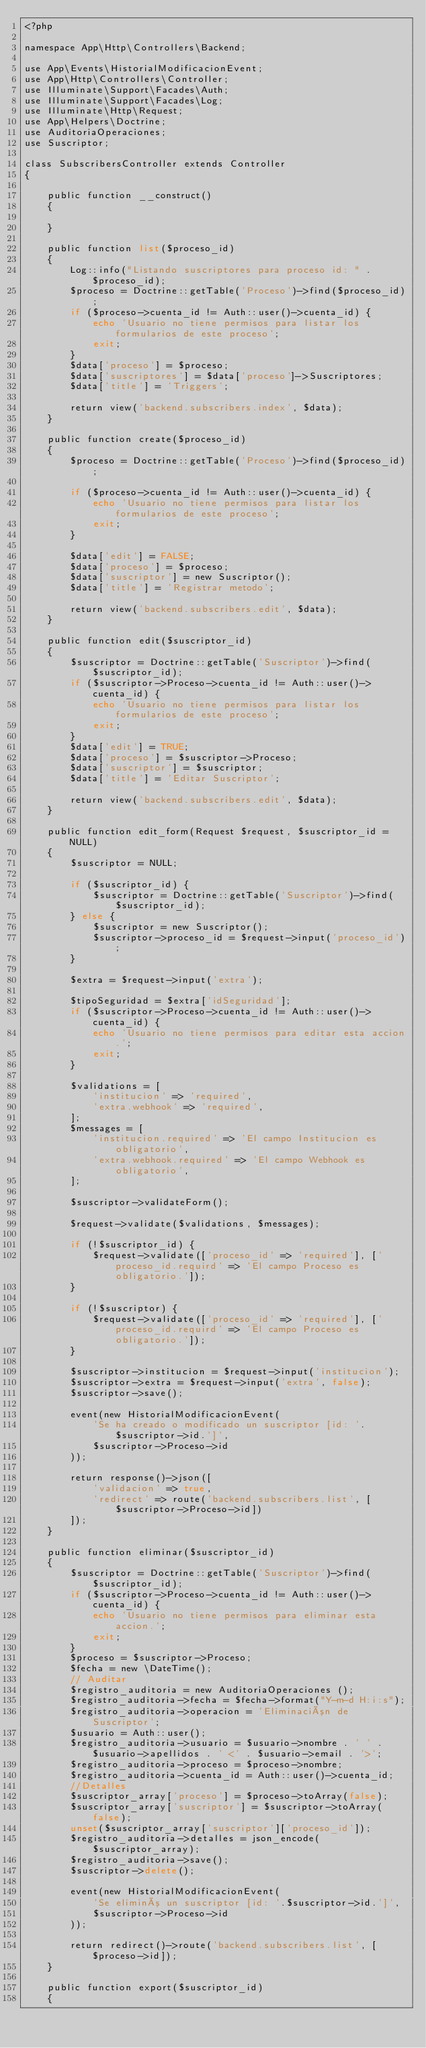Convert code to text. <code><loc_0><loc_0><loc_500><loc_500><_PHP_><?php

namespace App\Http\Controllers\Backend;

use App\Events\HistorialModificacionEvent;
use App\Http\Controllers\Controller;
use Illuminate\Support\Facades\Auth;
use Illuminate\Support\Facades\Log;
use Illuminate\Http\Request;
use App\Helpers\Doctrine;
use AuditoriaOperaciones;
use Suscriptor;

class SubscribersController extends Controller
{

    public function __construct()
    {

    }

    public function list($proceso_id)
    {
        Log::info("Listando suscriptores para proceso id: " . $proceso_id);
        $proceso = Doctrine::getTable('Proceso')->find($proceso_id);
        if ($proceso->cuenta_id != Auth::user()->cuenta_id) {
            echo 'Usuario no tiene permisos para listar los formularios de este proceso';
            exit;
        }
        $data['proceso'] = $proceso;
        $data['suscriptores'] = $data['proceso']->Suscriptores;
        $data['title'] = 'Triggers';

        return view('backend.subscribers.index', $data);
    }

    public function create($proceso_id)
    {
        $proceso = Doctrine::getTable('Proceso')->find($proceso_id);

        if ($proceso->cuenta_id != Auth::user()->cuenta_id) {
            echo 'Usuario no tiene permisos para listar los formularios de este proceso';
            exit;
        }

        $data['edit'] = FALSE;
        $data['proceso'] = $proceso;
        $data['suscriptor'] = new Suscriptor();
        $data['title'] = 'Registrar metodo';

        return view('backend.subscribers.edit', $data);
    }

    public function edit($suscriptor_id)
    {
        $suscriptor = Doctrine::getTable('Suscriptor')->find($suscriptor_id);
        if ($suscriptor->Proceso->cuenta_id != Auth::user()->cuenta_id) {
            echo 'Usuario no tiene permisos para listar los formularios de este proceso';
            exit;
        }
        $data['edit'] = TRUE;
        $data['proceso'] = $suscriptor->Proceso;
        $data['suscriptor'] = $suscriptor;
        $data['title'] = 'Editar Suscriptor';

        return view('backend.subscribers.edit', $data);
    }

    public function edit_form(Request $request, $suscriptor_id = NULL)
    {
        $suscriptor = NULL;

        if ($suscriptor_id) {
            $suscriptor = Doctrine::getTable('Suscriptor')->find($suscriptor_id);
        } else {
            $suscriptor = new Suscriptor();
            $suscriptor->proceso_id = $request->input('proceso_id');
        }

        $extra = $request->input('extra');

        $tipoSeguridad = $extra['idSeguridad'];
        if ($suscriptor->Proceso->cuenta_id != Auth::user()->cuenta_id) {
            echo 'Usuario no tiene permisos para editar esta accion.';
            exit;
        }

        $validations = [
            'institucion' => 'required',
            'extra.webhook' => 'required',
        ];
        $messages = [
            'institucion.required' => 'El campo Institucion es obligatorio',
            'extra.webhook.required' => 'El campo Webhook es obligatorio',
        ];

        $suscriptor->validateForm();

        $request->validate($validations, $messages);

        if (!$suscriptor_id) {
            $request->validate(['proceso_id' => 'required'], ['proceso_id.requird' => 'El campo Proceso es obligatorio.']);
        }

        if (!$suscriptor) {
            $request->validate(['proceso_id' => 'required'], ['proceso_id.requird' => 'El campo Proceso es obligatorio.']);
        }

        $suscriptor->institucion = $request->input('institucion');
        $suscriptor->extra = $request->input('extra', false);
        $suscriptor->save();

        event(new HistorialModificacionEvent(
            'Se ha creado o modificado un suscriptor [id: '.$suscriptor->id.']',
            $suscriptor->Proceso->id
        ));

        return response()->json([
            'validacion' => true,
            'redirect' => route('backend.subscribers.list', [$suscriptor->Proceso->id])
        ]);
    }

    public function eliminar($suscriptor_id)
    {
        $suscriptor = Doctrine::getTable('Suscriptor')->find($suscriptor_id);
        if ($suscriptor->Proceso->cuenta_id != Auth::user()->cuenta_id) {
            echo 'Usuario no tiene permisos para eliminar esta accion.';
            exit;
        }
        $proceso = $suscriptor->Proceso;
        $fecha = new \DateTime();
        // Auditar
        $registro_auditoria = new AuditoriaOperaciones ();
        $registro_auditoria->fecha = $fecha->format("Y-m-d H:i:s");
        $registro_auditoria->operacion = 'Eliminación de Suscriptor';
        $usuario = Auth::user();
        $registro_auditoria->usuario = $usuario->nombre . ' ' . $usuario->apellidos . ' <' . $usuario->email . '>';
        $registro_auditoria->proceso = $proceso->nombre;
        $registro_auditoria->cuenta_id = Auth::user()->cuenta_id;
        //Detalles
        $suscriptor_array['proceso'] = $proceso->toArray(false);
        $suscriptor_array['suscriptor'] = $suscriptor->toArray(false);
        unset($suscriptor_array['suscriptor']['proceso_id']);
        $registro_auditoria->detalles = json_encode($suscriptor_array);
        $registro_auditoria->save();
        $suscriptor->delete();

        event(new HistorialModificacionEvent(
            'Se eliminó un suscriptor [id: '.$suscriptor->id.']',
            $suscriptor->Proceso->id
        ));

        return redirect()->route('backend.subscribers.list', [$proceso->id]);
    }

    public function export($suscriptor_id)
    {
</code> 